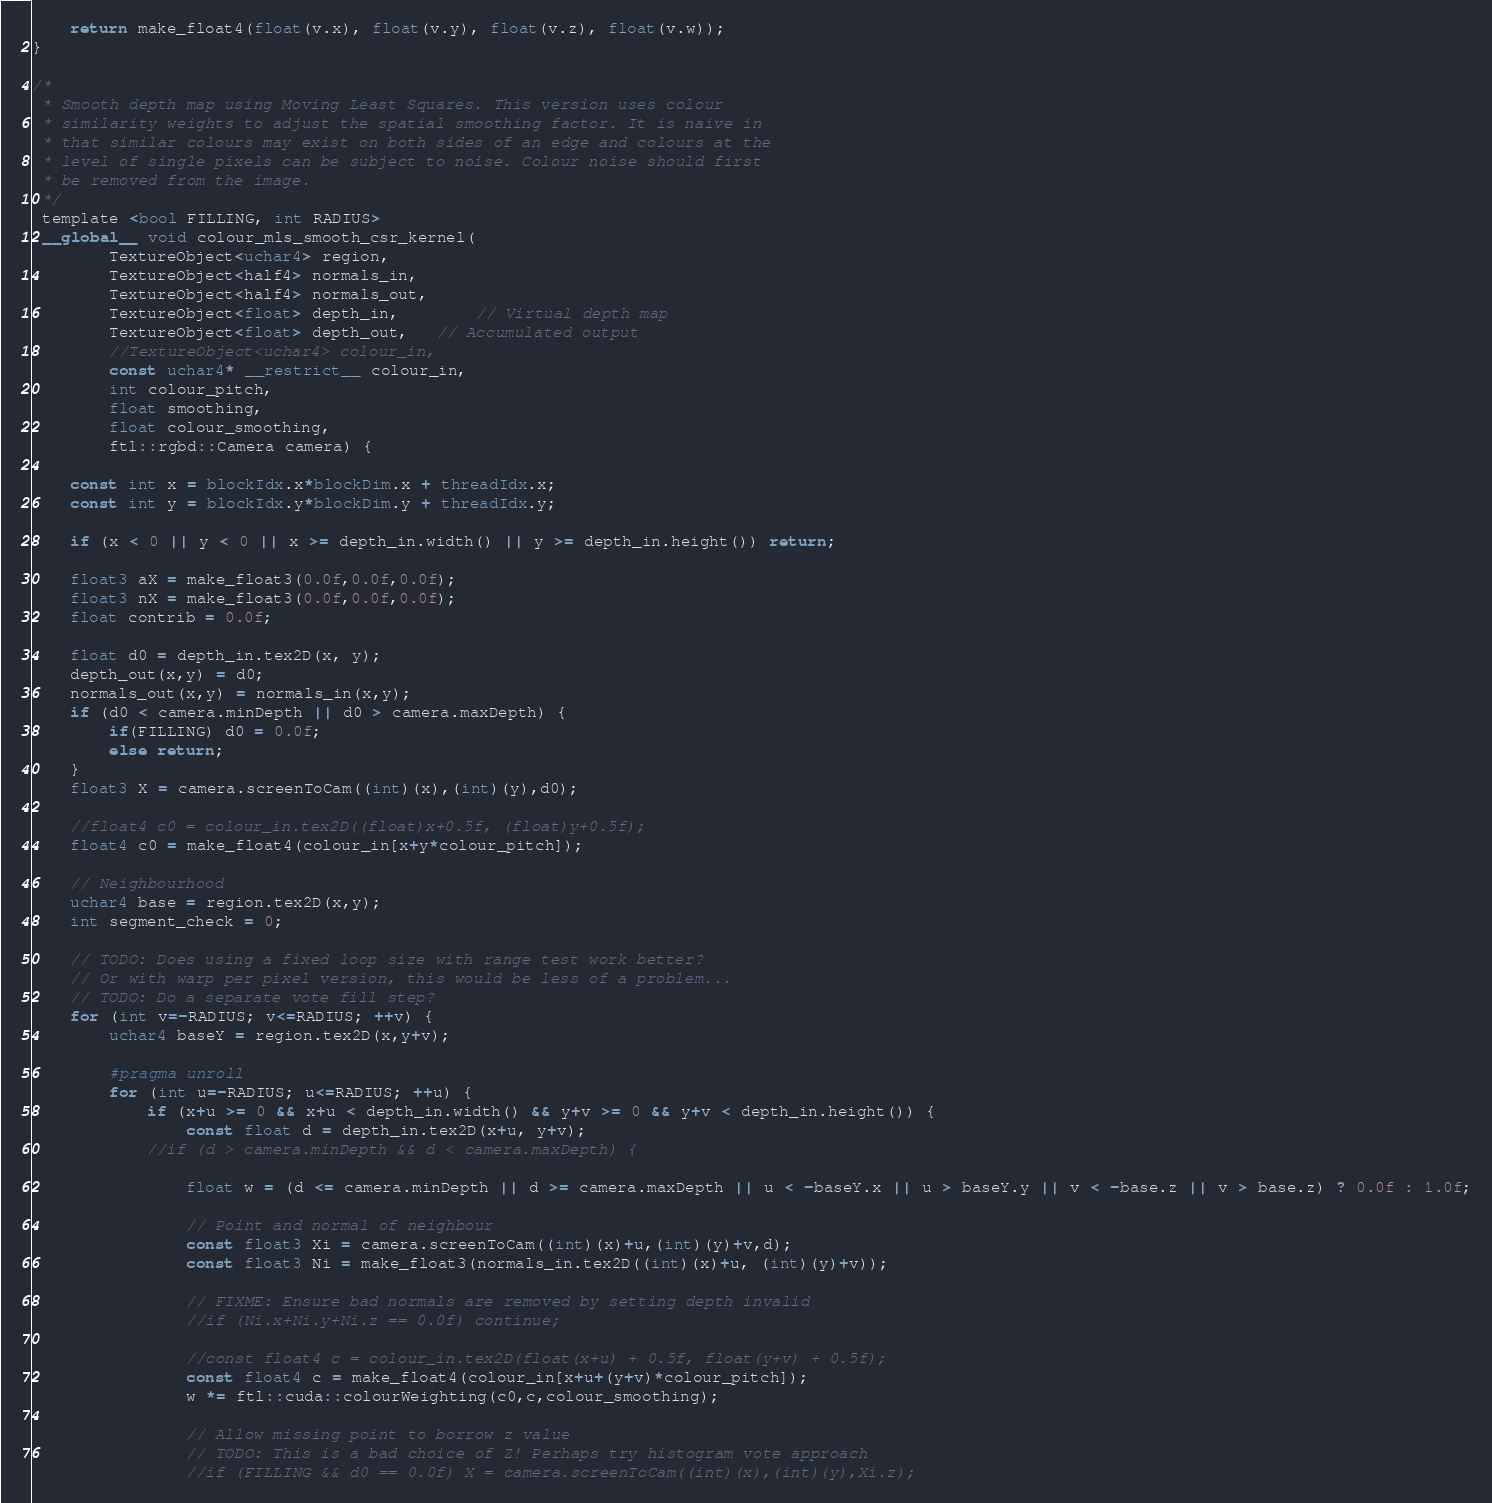<code> <loc_0><loc_0><loc_500><loc_500><_Cuda_>	return make_float4(float(v.x), float(v.y), float(v.z), float(v.w));
}

/*
 * Smooth depth map using Moving Least Squares. This version uses colour
 * similarity weights to adjust the spatial smoothing factor. It is naive in
 * that similar colours may exist on both sides of an edge and colours at the
 * level of single pixels can be subject to noise. Colour noise should first
 * be removed from the image.
 */
 template <bool FILLING, int RADIUS>
 __global__ void colour_mls_smooth_csr_kernel(
	 	TextureObject<uchar4> region,
		TextureObject<half4> normals_in,
		TextureObject<half4> normals_out,
        TextureObject<float> depth_in,        // Virtual depth map
		TextureObject<float> depth_out,   // Accumulated output
		//TextureObject<uchar4> colour_in,
		const uchar4* __restrict__ colour_in,
		int colour_pitch,
		float smoothing,
		float colour_smoothing,
        ftl::rgbd::Camera camera) {
        
    const int x = blockIdx.x*blockDim.x + threadIdx.x;
    const int y = blockIdx.y*blockDim.y + threadIdx.y;

    if (x < 0 || y < 0 || x >= depth_in.width() || y >= depth_in.height()) return;

	float3 aX = make_float3(0.0f,0.0f,0.0f);
	float3 nX = make_float3(0.0f,0.0f,0.0f);
    float contrib = 0.0f;

	float d0 = depth_in.tex2D(x, y);
	depth_out(x,y) = d0;
	normals_out(x,y) = normals_in(x,y);
	if (d0 < camera.minDepth || d0 > camera.maxDepth) {
		if(FILLING) d0 = 0.0f;
		else return;
	}
	float3 X = camera.screenToCam((int)(x),(int)(y),d0);

	//float4 c0 = colour_in.tex2D((float)x+0.5f, (float)y+0.5f);
	float4 c0 = make_float4(colour_in[x+y*colour_pitch]);

    // Neighbourhood
	uchar4 base = region.tex2D(x,y);
	int segment_check = 0;

	// TODO: Does using a fixed loop size with range test work better?
	// Or with warp per pixel version, this would be less of a problem...
	// TODO: Do a separate vote fill step?
	for (int v=-RADIUS; v<=RADIUS; ++v) {
		uchar4 baseY = region.tex2D(x,y+v);

		#pragma unroll
		for (int u=-RADIUS; u<=RADIUS; ++u) {
			if (x+u >= 0 && x+u < depth_in.width() && y+v >= 0 && y+v < depth_in.height()) {
				const float d = depth_in.tex2D(x+u, y+v);
			//if (d > camera.minDepth && d < camera.maxDepth) {

				float w = (d <= camera.minDepth || d >= camera.maxDepth || u < -baseY.x || u > baseY.y || v < -base.z || v > base.z) ? 0.0f : 1.0f;

				// Point and normal of neighbour
				const float3 Xi = camera.screenToCam((int)(x)+u,(int)(y)+v,d);
				const float3 Ni = make_float3(normals_in.tex2D((int)(x)+u, (int)(y)+v));

				// FIXME: Ensure bad normals are removed by setting depth invalid
				//if (Ni.x+Ni.y+Ni.z == 0.0f) continue;

				//const float4 c = colour_in.tex2D(float(x+u) + 0.5f, float(y+v) + 0.5f);
				const float4 c = make_float4(colour_in[x+u+(y+v)*colour_pitch]);
				w *= ftl::cuda::colourWeighting(c0,c,colour_smoothing);

				// Allow missing point to borrow z value
				// TODO: This is a bad choice of Z! Perhaps try histogram vote approach
				//if (FILLING && d0 == 0.0f) X = camera.screenToCam((int)(x),(int)(y),Xi.z);
</code> 